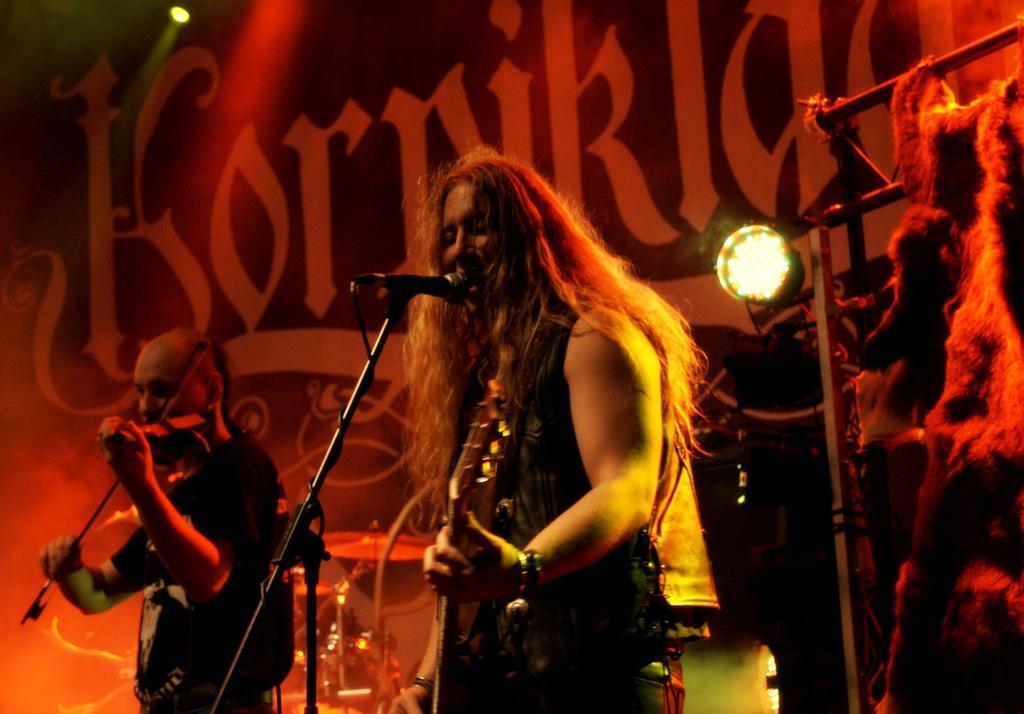Can you describe this image briefly? In this image, we can see a few people. We can see some microphones. We can see objects like lights, metal rods, musical instruments. In the background, we can see the poster with some text. 